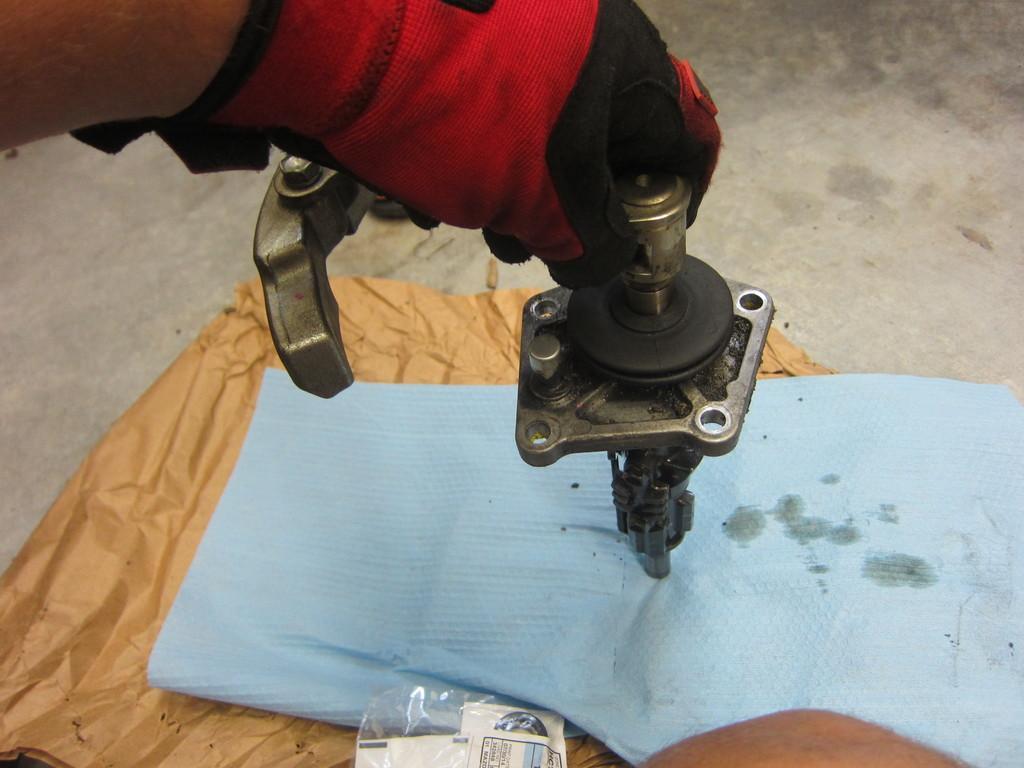In one or two sentences, can you explain what this image depicts? In this image a person's hand is visible. He is holding a machine which is kept on the covers. The covers are on the land. 